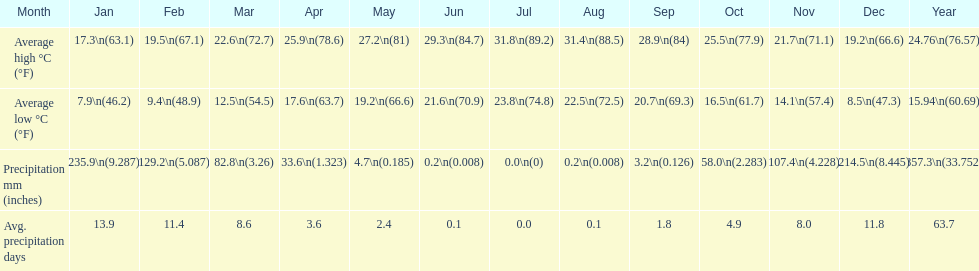What is the month with the lowest average low in haifa? January. 